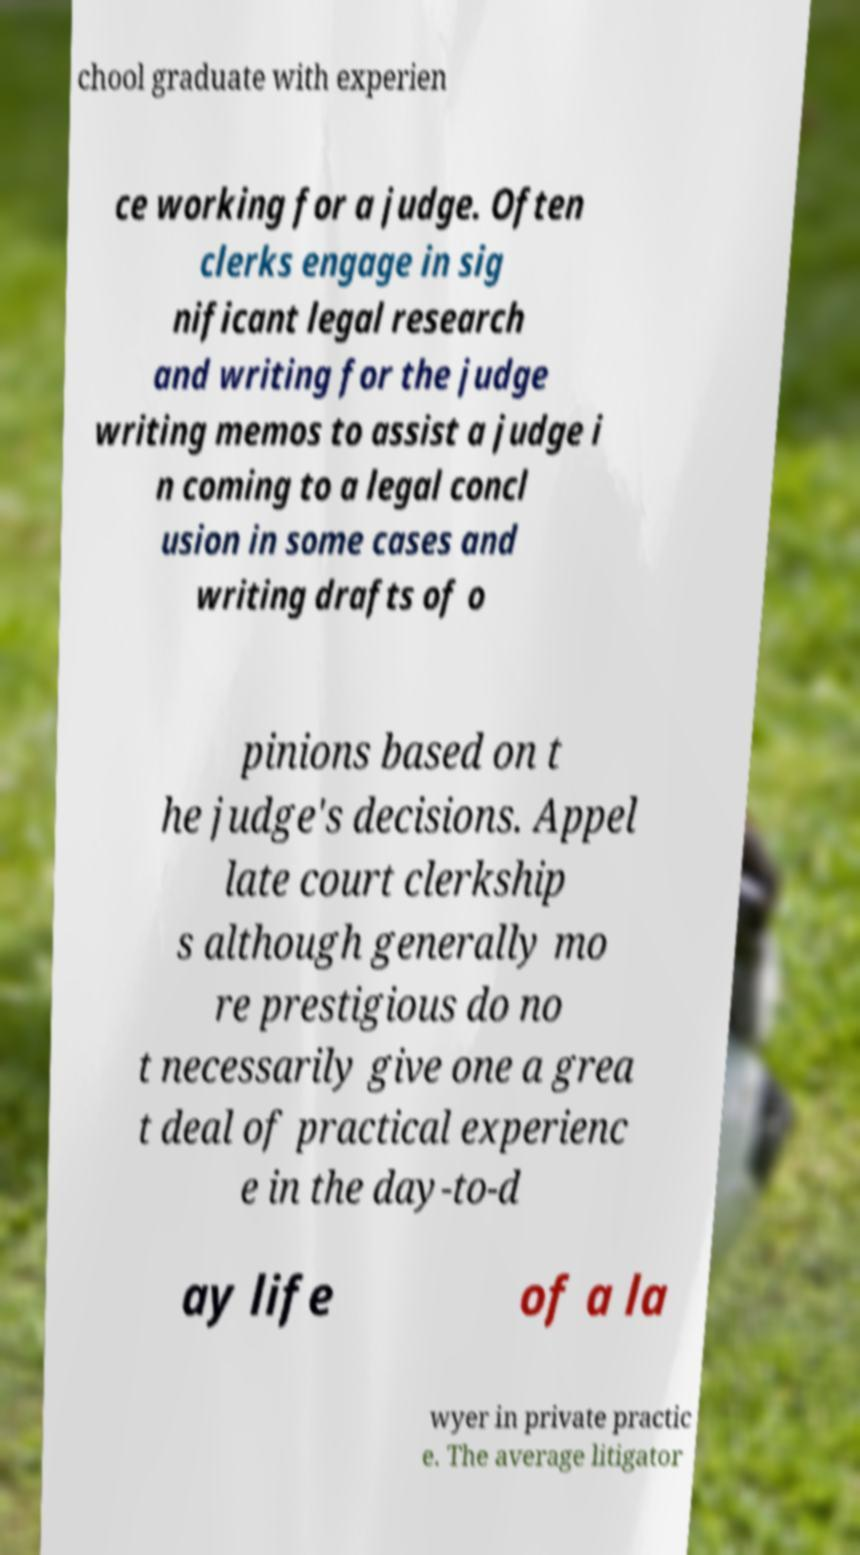What messages or text are displayed in this image? I need them in a readable, typed format. chool graduate with experien ce working for a judge. Often clerks engage in sig nificant legal research and writing for the judge writing memos to assist a judge i n coming to a legal concl usion in some cases and writing drafts of o pinions based on t he judge's decisions. Appel late court clerkship s although generally mo re prestigious do no t necessarily give one a grea t deal of practical experienc e in the day-to-d ay life of a la wyer in private practic e. The average litigator 